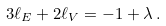Convert formula to latex. <formula><loc_0><loc_0><loc_500><loc_500>3 \ell _ { E } + 2 \ell _ { V } = - 1 + \lambda \, .</formula> 